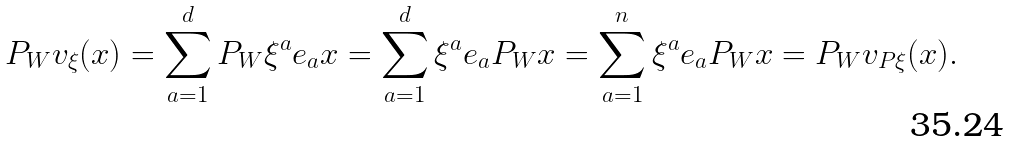<formula> <loc_0><loc_0><loc_500><loc_500>P _ { W } v _ { \xi } ( x ) = \sum _ { a = 1 } ^ { d } P _ { W } \xi ^ { a } e _ { a } x = \sum _ { a = 1 } ^ { d } \xi ^ { a } e _ { a } P _ { W } x = \sum _ { a = 1 } ^ { n } \xi ^ { a } e _ { a } P _ { W } x = P _ { W } v _ { P \xi } ( x ) .</formula> 